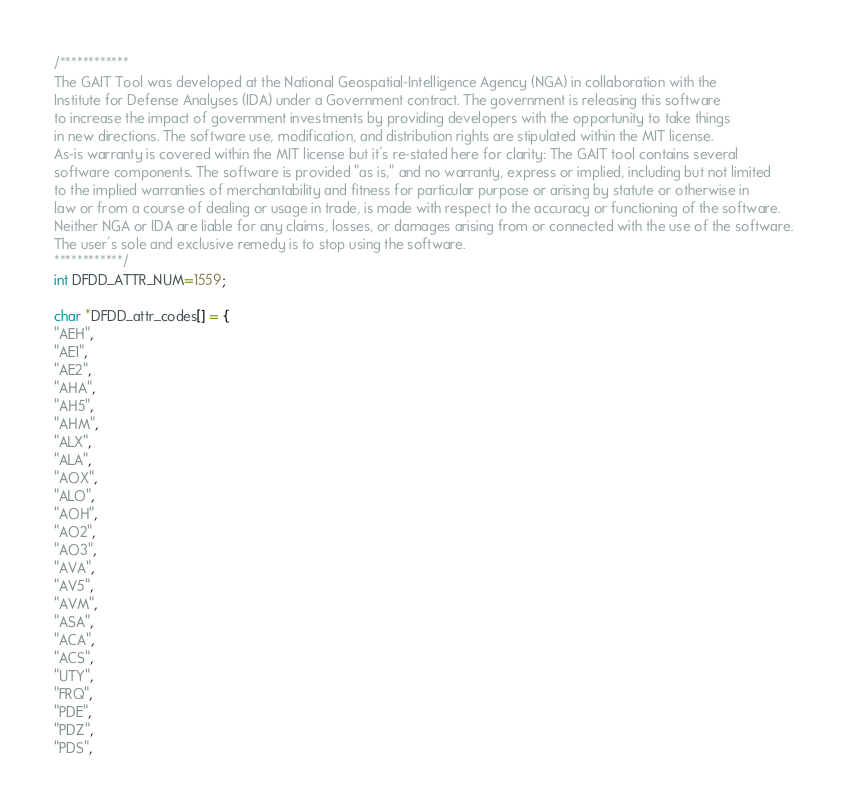<code> <loc_0><loc_0><loc_500><loc_500><_C_>/************
The GAIT Tool was developed at the National Geospatial-Intelligence Agency (NGA) in collaboration with the   
Institute for Defense Analyses (IDA) under a Government contract. The government is releasing this software   
to increase the impact of government investments by providing developers with the opportunity to take things   
in new directions. The software use, modification, and distribution rights are stipulated within the MIT license.
As-is warranty is covered within the MIT license but it's re-stated here for clarity: The GAIT tool contains several   
software components. The software is provided "as is," and no warranty, express or implied, including but not limited   
to the implied warranties of merchantability and fitness for particular purpose or arising by statute or otherwise in   
law or from a course of dealing or usage in trade, is made with respect to the accuracy or functioning of the software.   
Neither NGA or IDA are liable for any claims, losses, or damages arising from or connected with the use of the software.   
The user's sole and exclusive remedy is to stop using the software.
************/
int DFDD_ATTR_NUM=1559;

char *DFDD_attr_codes[] = {
"AEH",
"AE1",
"AE2",
"AHA",
"AH5",
"AHM",
"ALX",
"ALA",
"AOX",
"ALO",
"AOH",
"AO2",
"AO3",
"AVA",
"AV5",
"AVM",
"ASA",
"ACA",
"ACS",
"UTY",
"FRQ",
"PDE",
"PDZ",
"PDS",</code> 